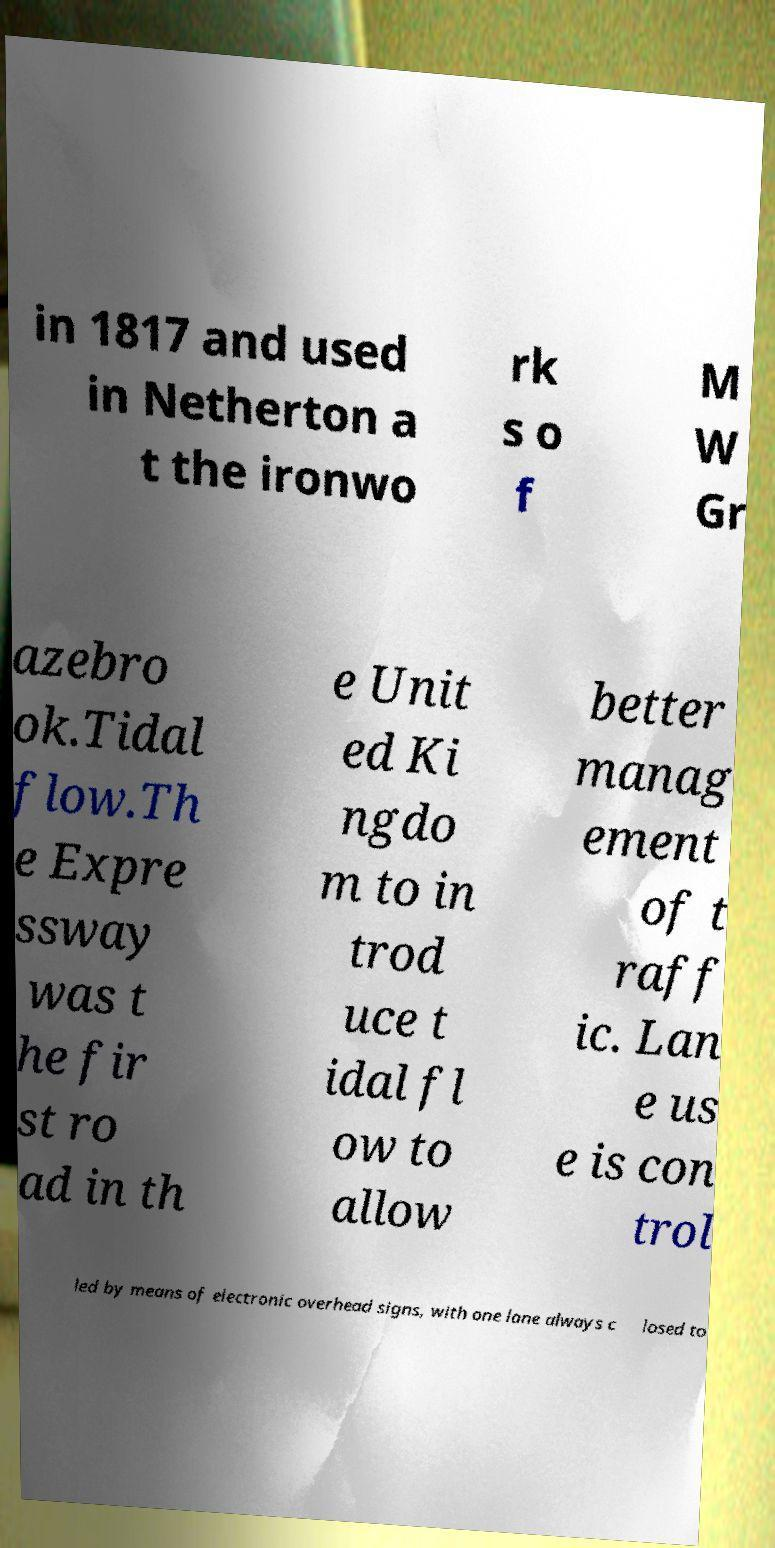For documentation purposes, I need the text within this image transcribed. Could you provide that? in 1817 and used in Netherton a t the ironwo rk s o f M W Gr azebro ok.Tidal flow.Th e Expre ssway was t he fir st ro ad in th e Unit ed Ki ngdo m to in trod uce t idal fl ow to allow better manag ement of t raff ic. Lan e us e is con trol led by means of electronic overhead signs, with one lane always c losed to 